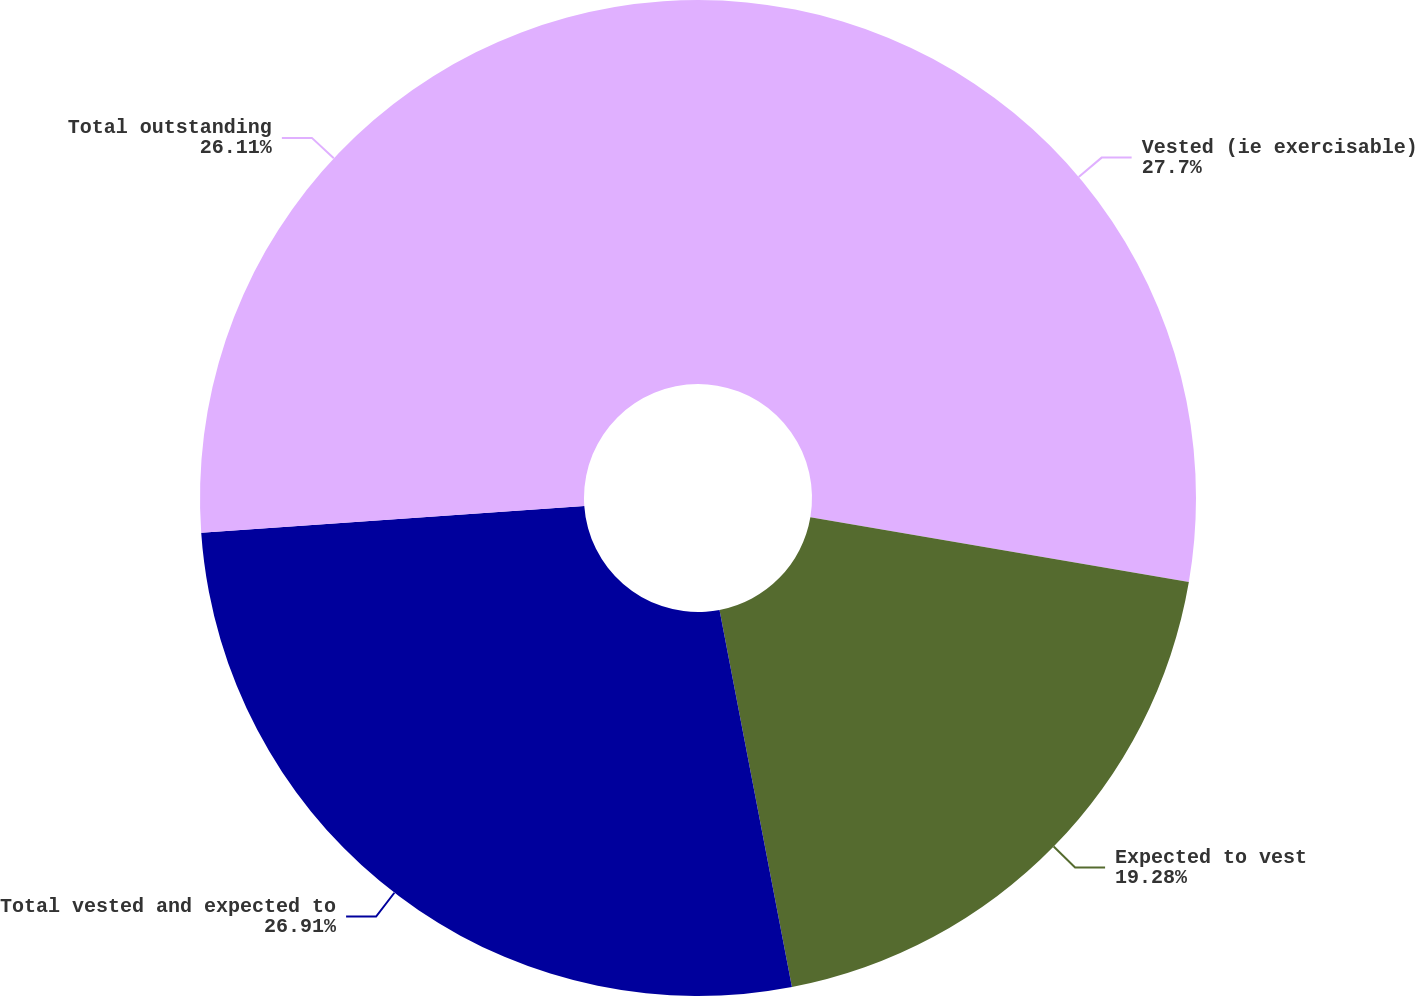<chart> <loc_0><loc_0><loc_500><loc_500><pie_chart><fcel>Vested (ie exercisable)<fcel>Expected to vest<fcel>Total vested and expected to<fcel>Total outstanding<nl><fcel>27.7%<fcel>19.28%<fcel>26.91%<fcel>26.11%<nl></chart> 